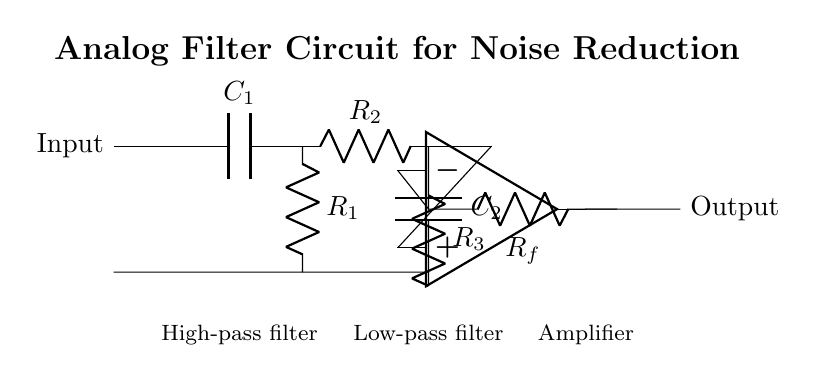What type of filters are present in this circuit? The circuit contains a high-pass filter and a low-pass filter, which are indicated by separate sections of the schematic diagram labeled accordingly.
Answer: high-pass filter and low-pass filter What is the role of the amplifier in this circuit? The amplifier increases the signal level after passing through the filters, and it is visible as a component following the filters in the diagram.
Answer: Signal amplification What components are used in the high-pass filter? The high-pass filter includes a capacitor labeled C1 and a resistor labeled R1, which are shown distinctly in the upper section of the circuit.
Answer: C1 and R1 What is the connection point between the high-pass and low-pass filters? The connection point is where the output of the high-pass filter connects to the input of the low-pass filter, specifically where R1 and R2 are located.
Answer: Between R1 and R2 How does the noise reduction work in this circuit? Noise reduction is achieved by using both filter types; the high-pass filter eliminates low-frequency noise, while the low-pass filter removes high-frequency noise, allowing only the desired signal to pass.
Answer: Through filtering What is the value of feedback resistor in the amplifier? The feedback resistor in the amplifier section is labeled Rf, indicating that it is part of the feedback loop for stability and gain control in the amplifier circuit.
Answer: Rf 